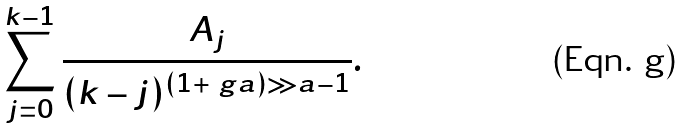Convert formula to latex. <formula><loc_0><loc_0><loc_500><loc_500>\sum _ { j = 0 } ^ { k - 1 } \frac { A _ { j } } { ( k - j ) ^ { ( 1 + \ g a ) \gg a - 1 } } .</formula> 